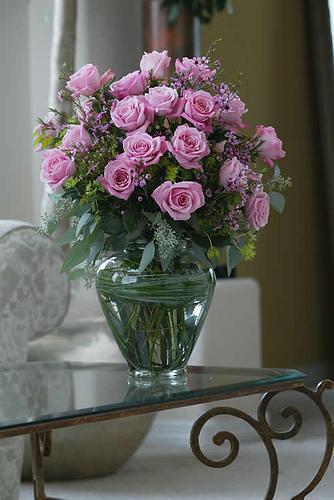How many people are there?
Give a very brief answer. 0. How many vases are there?
Give a very brief answer. 1. How many onions?
Give a very brief answer. 0. 